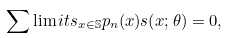Convert formula to latex. <formula><loc_0><loc_0><loc_500><loc_500>\sum \lim i t s _ { { x } \in \mathbb { S } } p _ { n } ( { x } ) s ( { x } ; \theta ) = 0 ,</formula> 